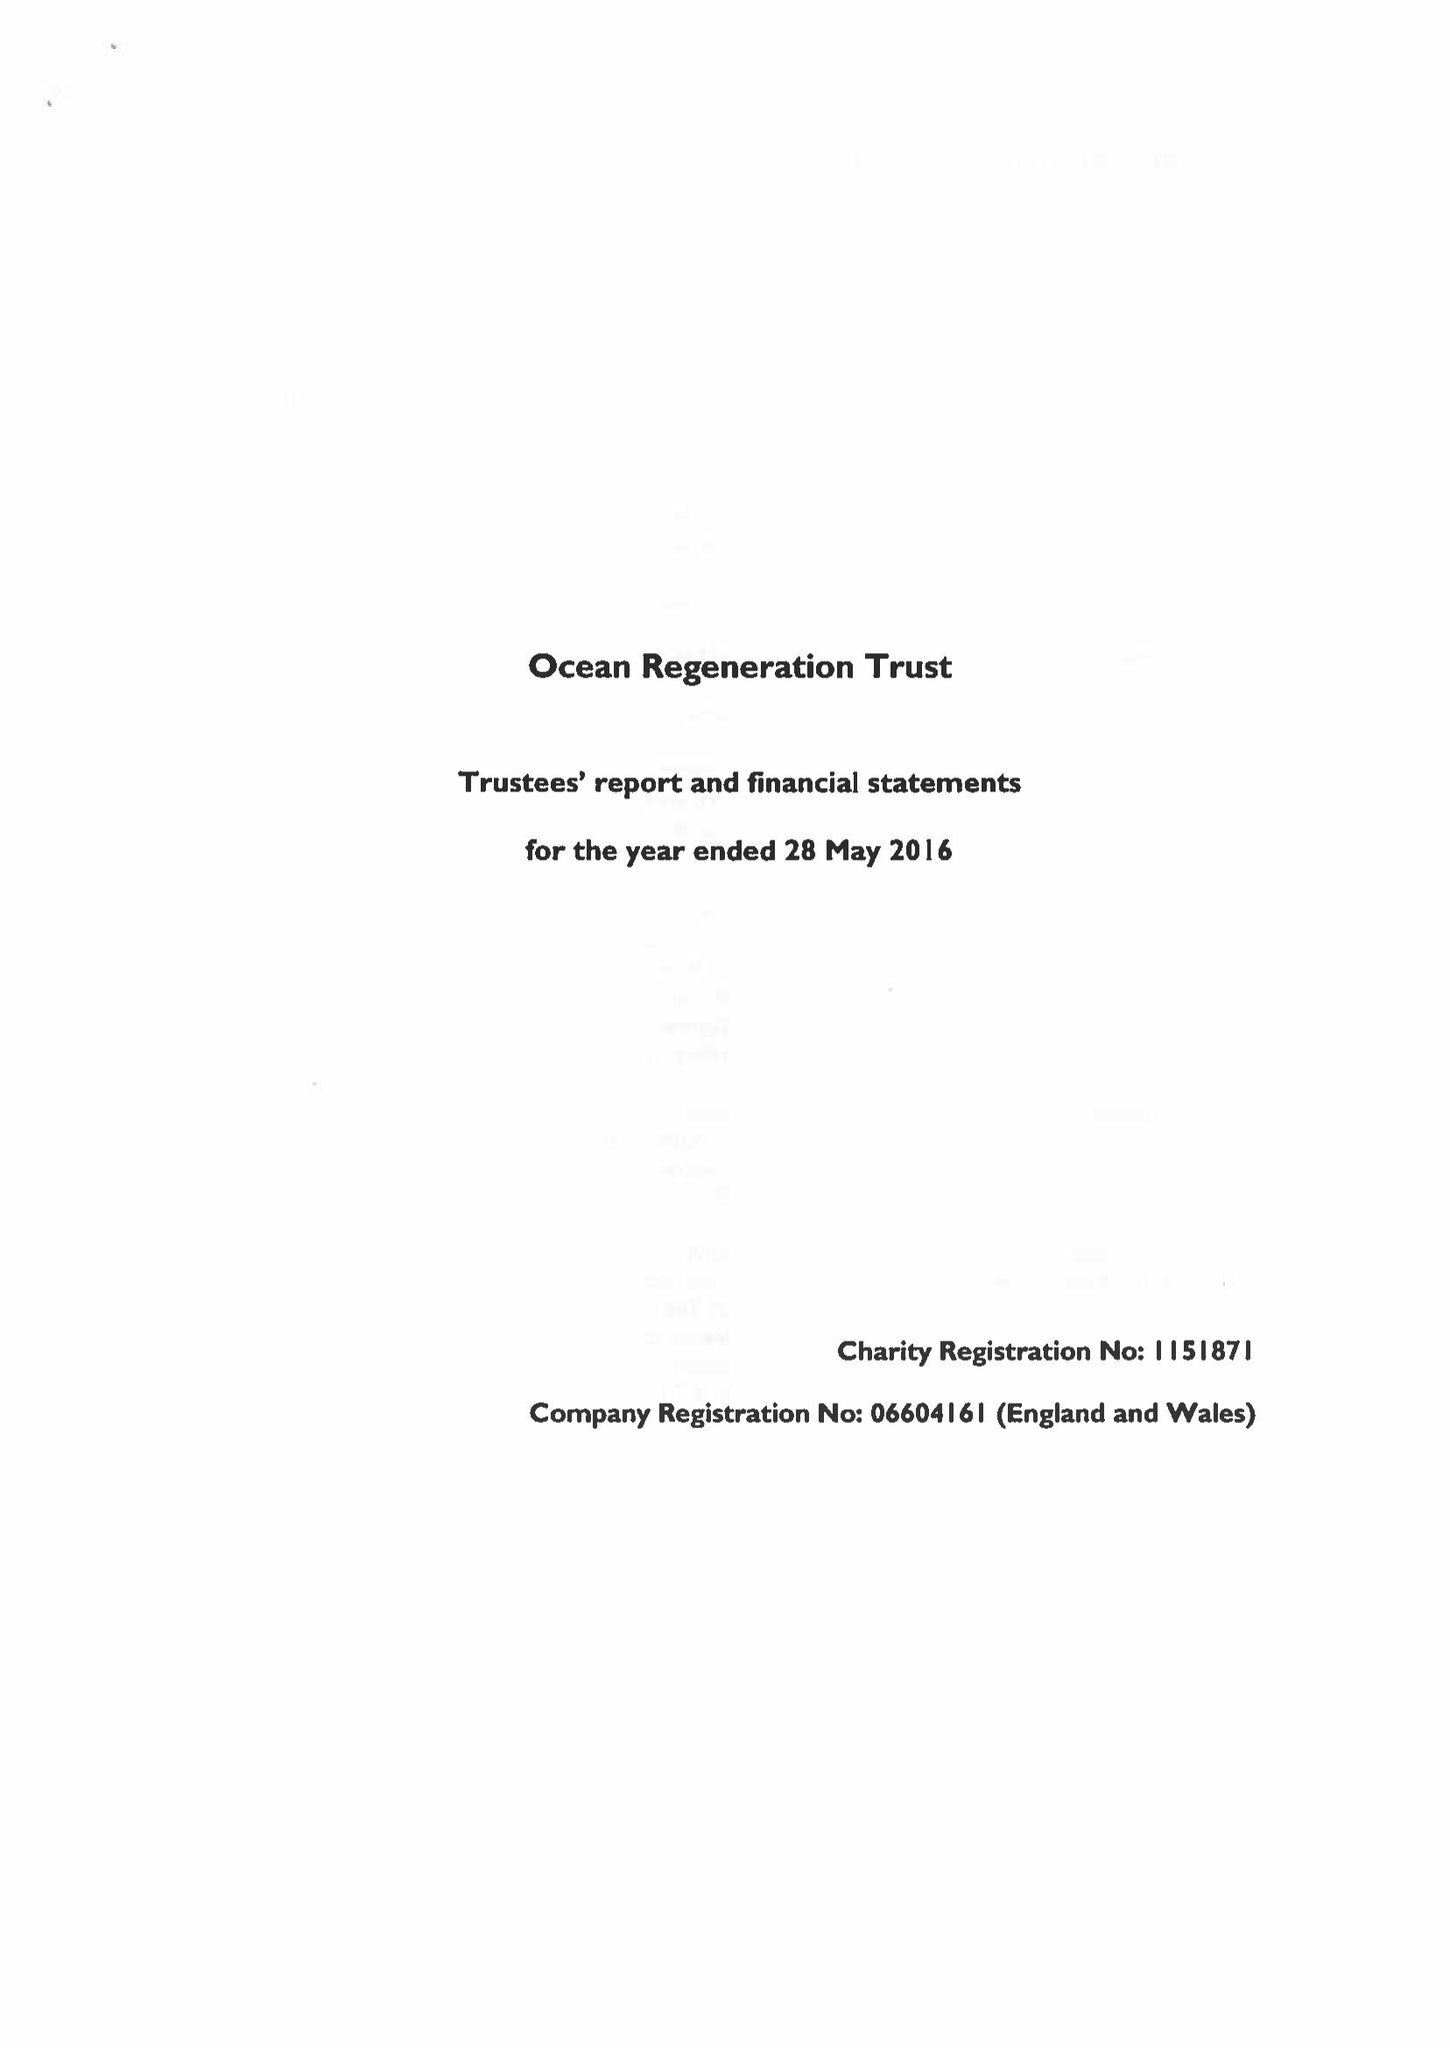What is the value for the address__post_town?
Answer the question using a single word or phrase. LONDON 